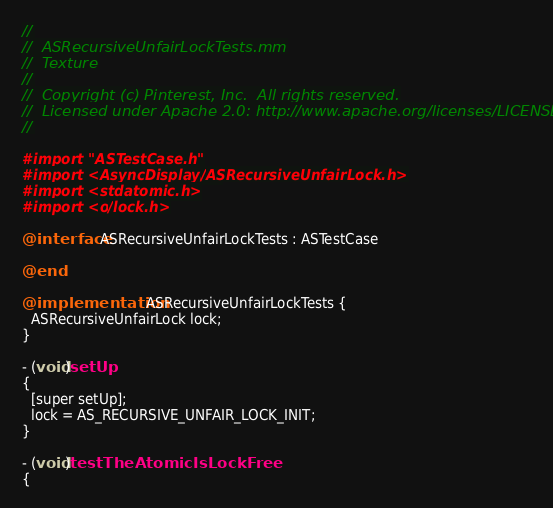Convert code to text. <code><loc_0><loc_0><loc_500><loc_500><_ObjectiveC_>//
//  ASRecursiveUnfairLockTests.mm
//  Texture
//
//  Copyright (c) Pinterest, Inc.  All rights reserved.
//  Licensed under Apache 2.0: http://www.apache.org/licenses/LICENSE-2.0
//

#import "ASTestCase.h"
#import <AsyncDisplayKit/ASRecursiveUnfairLock.h>
#import <stdatomic.h>
#import <os/lock.h>

@interface ASRecursiveUnfairLockTests : ASTestCase

@end

@implementation ASRecursiveUnfairLockTests {
  ASRecursiveUnfairLock lock;
}

- (void)setUp
{
  [super setUp];
  lock = AS_RECURSIVE_UNFAIR_LOCK_INIT;
}

- (void)testTheAtomicIsLockFree
{</code> 